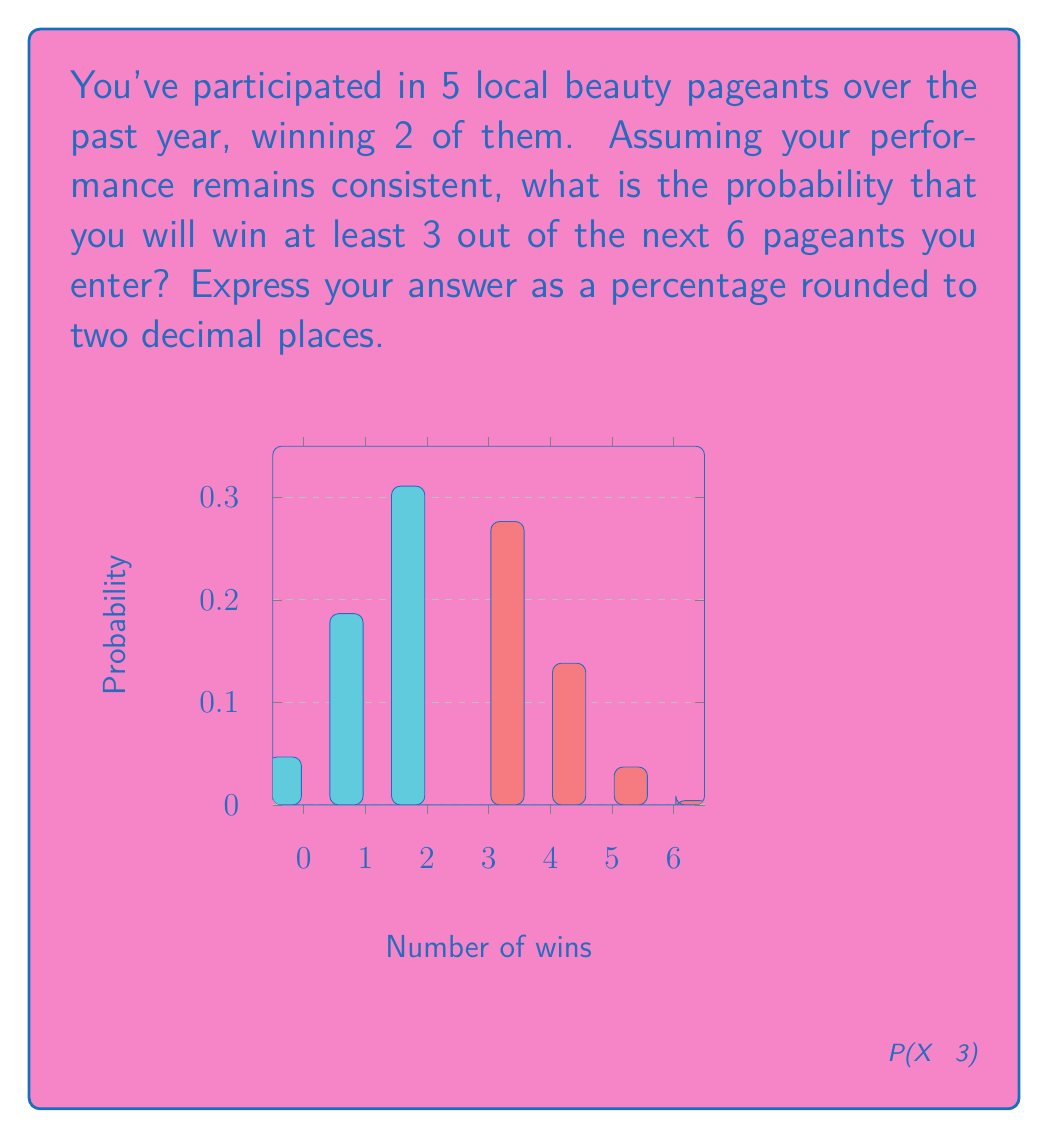What is the answer to this math problem? Let's approach this step-by-step:

1) First, we need to determine the probability of winning a single pageant based on past data:
   $p = \frac{\text{number of wins}}{\text{total pageants}} = \frac{2}{5} = 0.4$ or 40%

2) Now, we're looking at the probability of winning at least 3 out of 6 future pageants. This can be modeled as a binomial distribution with $n = 6$ trials and $p = 0.4$.

3) The probability of winning at least 3 pageants is the sum of the probabilities of winning 3, 4, 5, or 6 pageants:

   $P(X \geq 3) = P(X = 3) + P(X = 4) + P(X = 5) + P(X = 6)$

4) We can calculate each of these using the binomial probability formula:

   $P(X = k) = \binom{n}{k} p^k (1-p)^{n-k}$

   Where $\binom{n}{k}$ is the binomial coefficient.

5) Let's calculate each term:

   $P(X = 3) = \binom{6}{3} (0.4)^3 (0.6)^3 = 20 \times 0.064 \times 0.216 = 0.27648$

   $P(X = 4) = \binom{6}{4} (0.4)^4 (0.6)^2 = 15 \times 0.0256 \times 0.36 = 0.13824$

   $P(X = 5) = \binom{6}{5} (0.4)^5 (0.6)^1 = 6 \times 0.01024 \times 0.6 = 0.036864$

   $P(X = 6) = \binom{6}{6} (0.4)^6 (0.6)^0 = 1 \times 0.004096 \times 1 = 0.004096$

6) Sum these probabilities:

   $P(X \geq 3) = 0.27648 + 0.13824 + 0.036864 + 0.004096 = 0.45568$

7) Convert to a percentage and round to two decimal places:

   $0.45568 \times 100 = 45.57\%$
Answer: 45.57% 